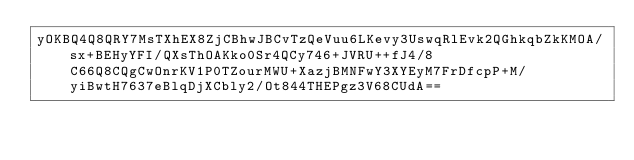Convert code to text. <code><loc_0><loc_0><loc_500><loc_500><_SML_>yOKBQ4Q8QRY7MsTXhEX8ZjCBhwJBCvTzQeVuu6LKevy3UswqRlEvk2QGhkqbZkKMOA/sx+BEHyYFI/QXsThOAKko0Sr4QCy746+JVRU++fJ4/8C66Q8CQgCwOnrKV1P0TZourMWU+XazjBMNFwY3XYEyM7FrDfcpP+M/yiBwtH7637eBlqDjXCbly2/Ot844THEPgz3V68CUdA==</code> 